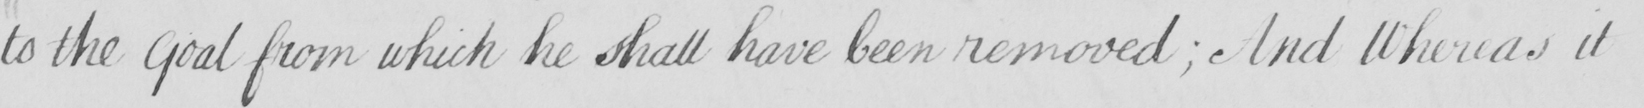Transcribe the text shown in this historical manuscript line. to the Goal from which he shall have been removed  ; And Whereas it 